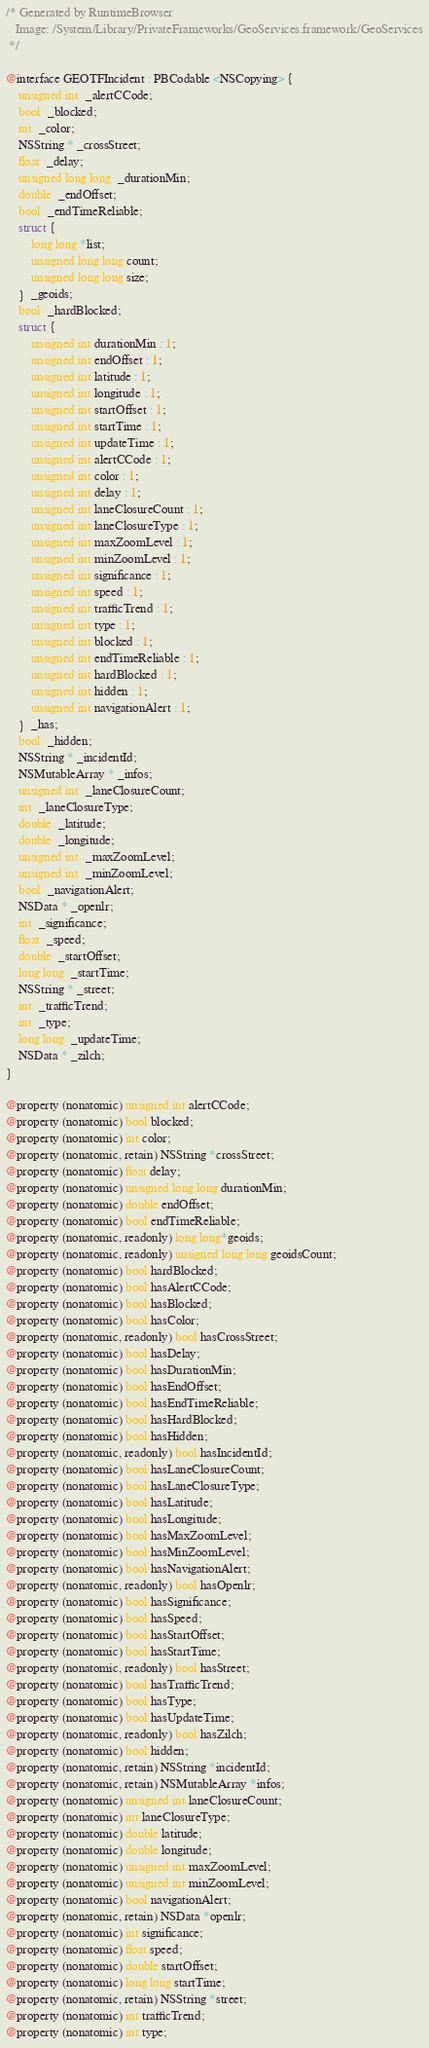Convert code to text. <code><loc_0><loc_0><loc_500><loc_500><_C_>/* Generated by RuntimeBrowser
   Image: /System/Library/PrivateFrameworks/GeoServices.framework/GeoServices
 */

@interface GEOTFIncident : PBCodable <NSCopying> {
    unsigned int  _alertCCode;
    bool  _blocked;
    int  _color;
    NSString * _crossStreet;
    float  _delay;
    unsigned long long  _durationMin;
    double  _endOffset;
    bool  _endTimeReliable;
    struct { 
        long long *list; 
        unsigned long long count; 
        unsigned long long size; 
    }  _geoids;
    bool  _hardBlocked;
    struct { 
        unsigned int durationMin : 1; 
        unsigned int endOffset : 1; 
        unsigned int latitude : 1; 
        unsigned int longitude : 1; 
        unsigned int startOffset : 1; 
        unsigned int startTime : 1; 
        unsigned int updateTime : 1; 
        unsigned int alertCCode : 1; 
        unsigned int color : 1; 
        unsigned int delay : 1; 
        unsigned int laneClosureCount : 1; 
        unsigned int laneClosureType : 1; 
        unsigned int maxZoomLevel : 1; 
        unsigned int minZoomLevel : 1; 
        unsigned int significance : 1; 
        unsigned int speed : 1; 
        unsigned int trafficTrend : 1; 
        unsigned int type : 1; 
        unsigned int blocked : 1; 
        unsigned int endTimeReliable : 1; 
        unsigned int hardBlocked : 1; 
        unsigned int hidden : 1; 
        unsigned int navigationAlert : 1; 
    }  _has;
    bool  _hidden;
    NSString * _incidentId;
    NSMutableArray * _infos;
    unsigned int  _laneClosureCount;
    int  _laneClosureType;
    double  _latitude;
    double  _longitude;
    unsigned int  _maxZoomLevel;
    unsigned int  _minZoomLevel;
    bool  _navigationAlert;
    NSData * _openlr;
    int  _significance;
    float  _speed;
    double  _startOffset;
    long long  _startTime;
    NSString * _street;
    int  _trafficTrend;
    int  _type;
    long long  _updateTime;
    NSData * _zilch;
}

@property (nonatomic) unsigned int alertCCode;
@property (nonatomic) bool blocked;
@property (nonatomic) int color;
@property (nonatomic, retain) NSString *crossStreet;
@property (nonatomic) float delay;
@property (nonatomic) unsigned long long durationMin;
@property (nonatomic) double endOffset;
@property (nonatomic) bool endTimeReliable;
@property (nonatomic, readonly) long long*geoids;
@property (nonatomic, readonly) unsigned long long geoidsCount;
@property (nonatomic) bool hardBlocked;
@property (nonatomic) bool hasAlertCCode;
@property (nonatomic) bool hasBlocked;
@property (nonatomic) bool hasColor;
@property (nonatomic, readonly) bool hasCrossStreet;
@property (nonatomic) bool hasDelay;
@property (nonatomic) bool hasDurationMin;
@property (nonatomic) bool hasEndOffset;
@property (nonatomic) bool hasEndTimeReliable;
@property (nonatomic) bool hasHardBlocked;
@property (nonatomic) bool hasHidden;
@property (nonatomic, readonly) bool hasIncidentId;
@property (nonatomic) bool hasLaneClosureCount;
@property (nonatomic) bool hasLaneClosureType;
@property (nonatomic) bool hasLatitude;
@property (nonatomic) bool hasLongitude;
@property (nonatomic) bool hasMaxZoomLevel;
@property (nonatomic) bool hasMinZoomLevel;
@property (nonatomic) bool hasNavigationAlert;
@property (nonatomic, readonly) bool hasOpenlr;
@property (nonatomic) bool hasSignificance;
@property (nonatomic) bool hasSpeed;
@property (nonatomic) bool hasStartOffset;
@property (nonatomic) bool hasStartTime;
@property (nonatomic, readonly) bool hasStreet;
@property (nonatomic) bool hasTrafficTrend;
@property (nonatomic) bool hasType;
@property (nonatomic) bool hasUpdateTime;
@property (nonatomic, readonly) bool hasZilch;
@property (nonatomic) bool hidden;
@property (nonatomic, retain) NSString *incidentId;
@property (nonatomic, retain) NSMutableArray *infos;
@property (nonatomic) unsigned int laneClosureCount;
@property (nonatomic) int laneClosureType;
@property (nonatomic) double latitude;
@property (nonatomic) double longitude;
@property (nonatomic) unsigned int maxZoomLevel;
@property (nonatomic) unsigned int minZoomLevel;
@property (nonatomic) bool navigationAlert;
@property (nonatomic, retain) NSData *openlr;
@property (nonatomic) int significance;
@property (nonatomic) float speed;
@property (nonatomic) double startOffset;
@property (nonatomic) long long startTime;
@property (nonatomic, retain) NSString *street;
@property (nonatomic) int trafficTrend;
@property (nonatomic) int type;</code> 